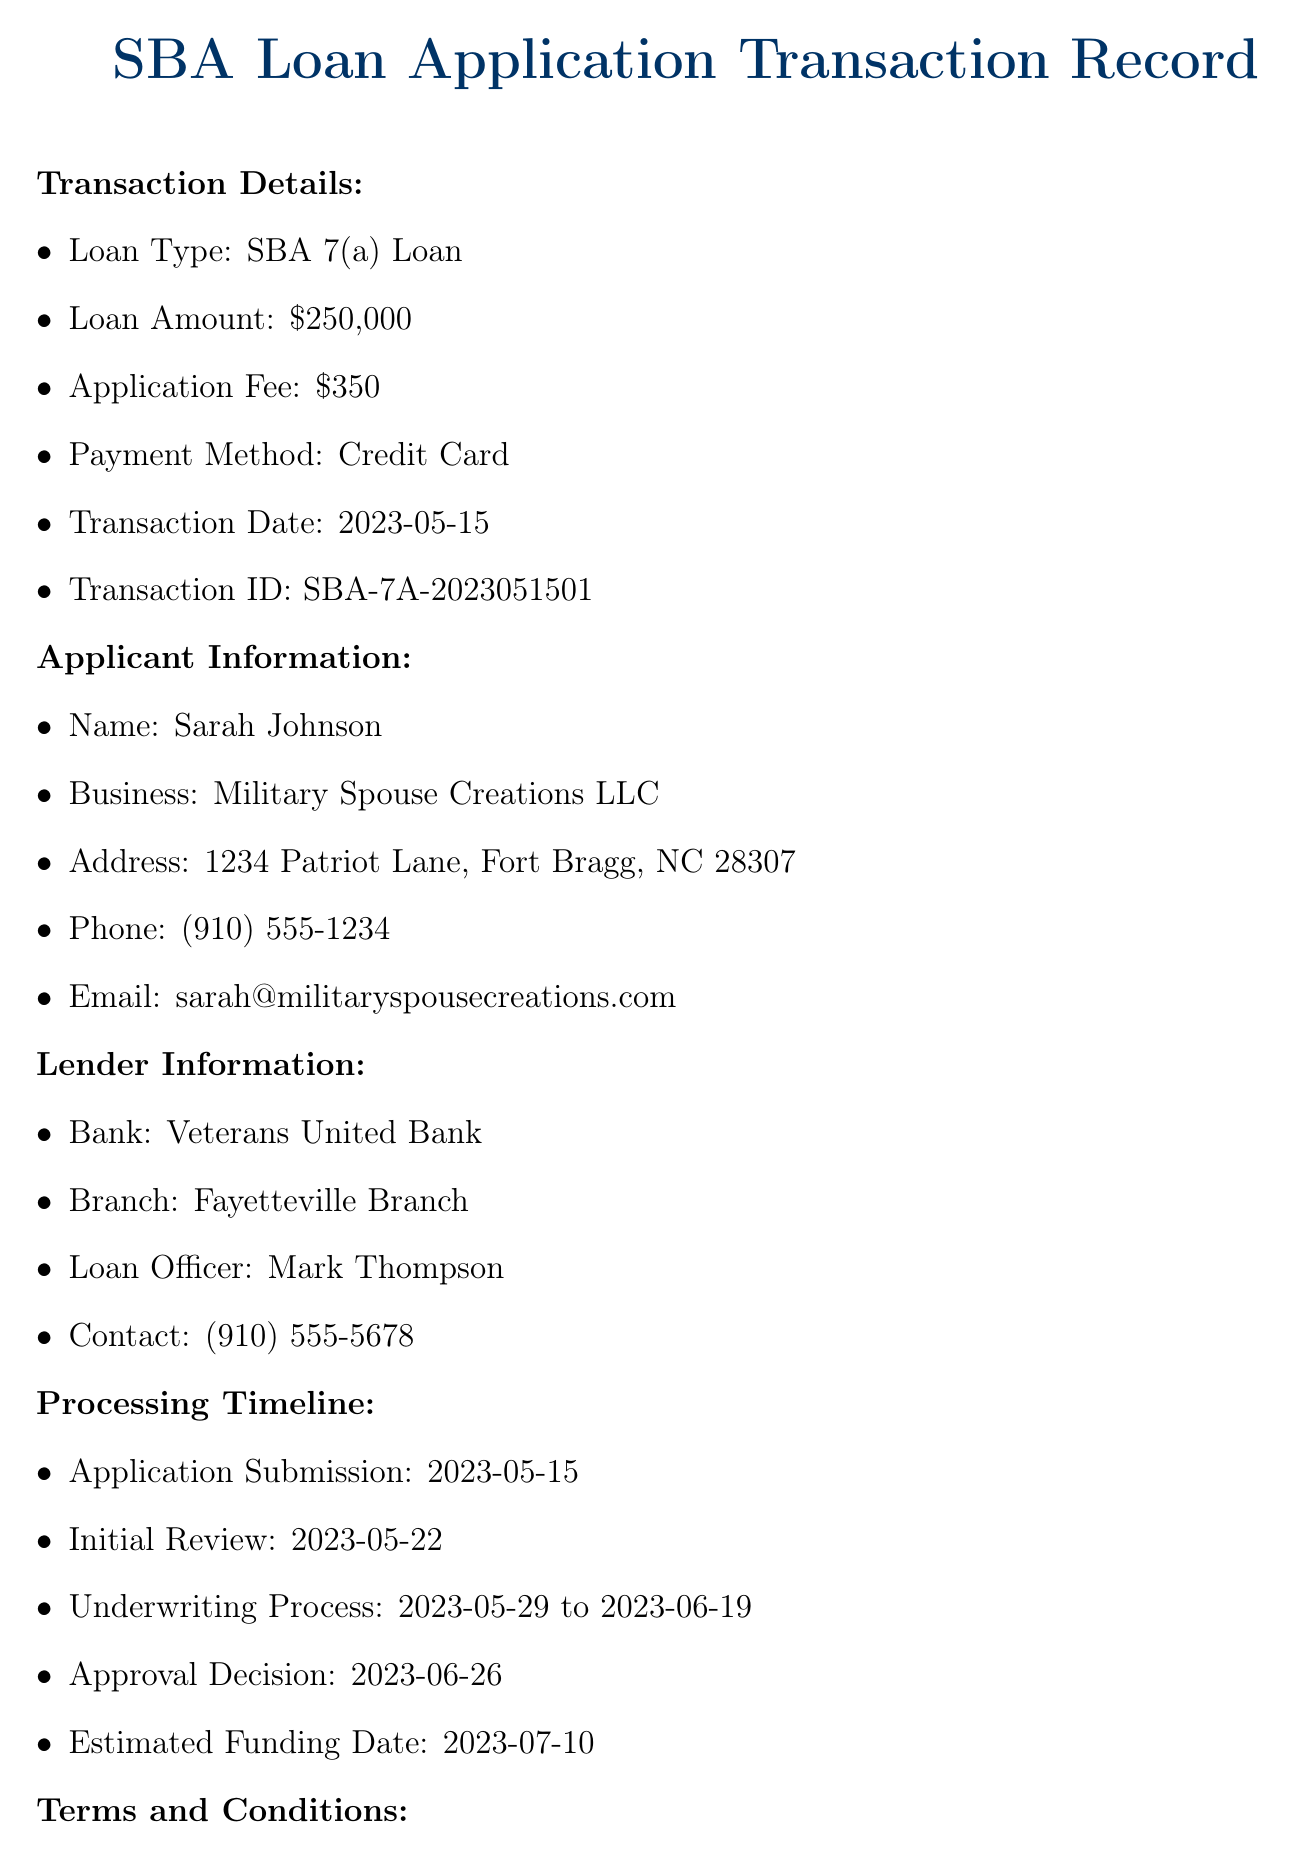What is the loan type? The document states that the loan type is specifically mentioned in the transaction details.
Answer: SBA 7(a) Loan What is the application fee amount? The transaction details specify the application fee associated with the SBA loan application.
Answer: $350 What is the estimated funding date? The processing timeline section lists the estimated funding date for the loan application.
Answer: 2023-07-10 Who is the loan officer? The lender information section includes the name of the loan officer responsible for the transaction.
Answer: Mark Thompson How many business days is the processing time? The terms and conditions specify the expected processing time for the application.
Answer: 30-45 business days What documents are required for the loan application? The terms and conditions list the essential documents needed along with the application.
Answer: Business plan, Financial statements, Tax returns (personal and business), Military spouse documentation, Business licenses and permits What is the guarantee fee percentage? The additional fees in the terms and conditions specify the percentage for the guarantee fee.
Answer: 2% What is the location of the North Carolina District Office? The document provides the address for the local SBA office in the resources section.
Answer: 6302 Fairview Road, Suite 300, Charlotte, NC 28210 What program is specifically for military spouses? The military spouse specific information section highlights a particular program designed for military spouses.
Answer: Military Spouse Business Partnership Program 